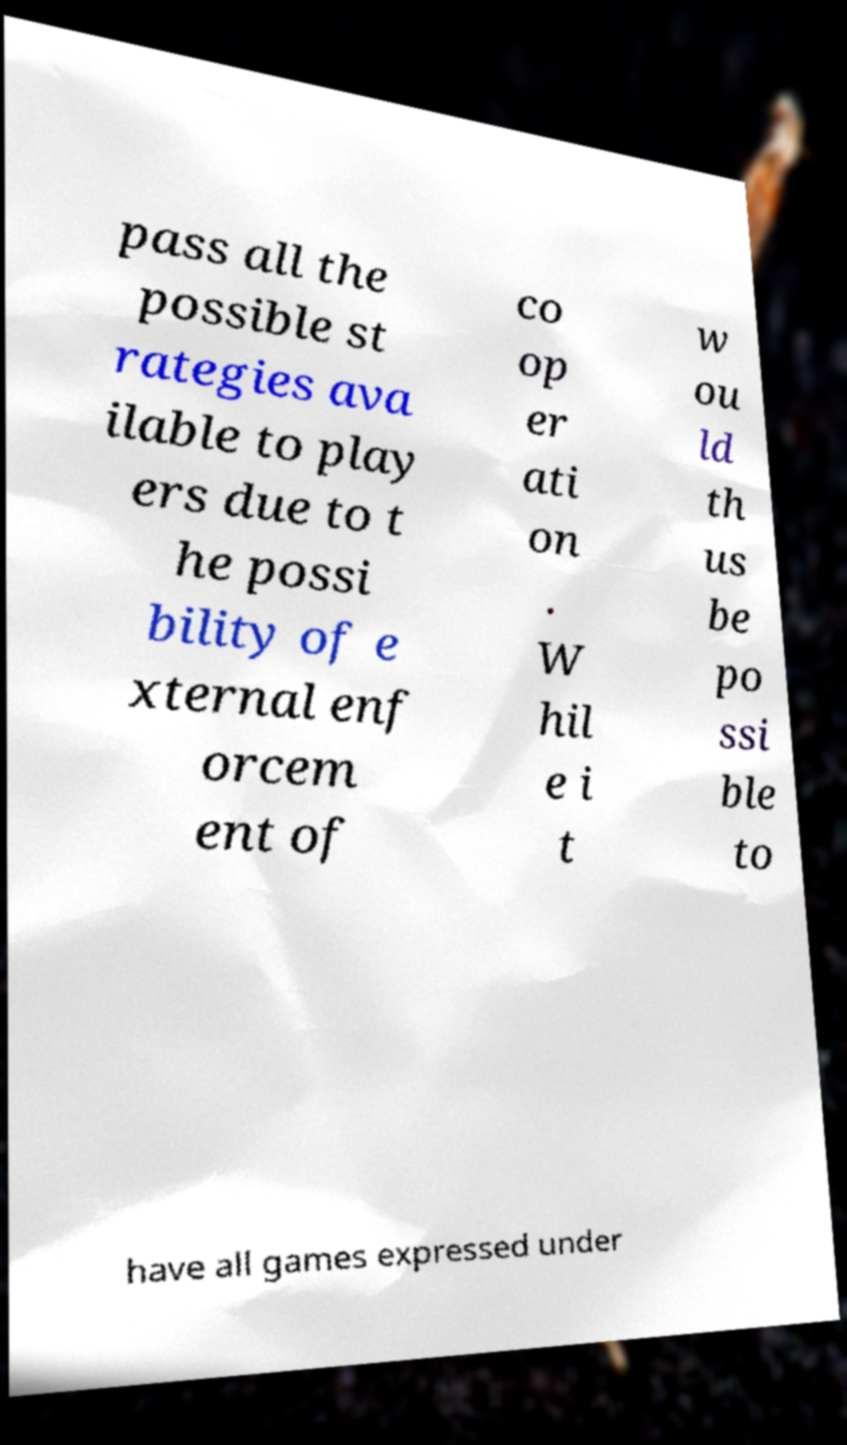Please identify and transcribe the text found in this image. pass all the possible st rategies ava ilable to play ers due to t he possi bility of e xternal enf orcem ent of co op er ati on . W hil e i t w ou ld th us be po ssi ble to have all games expressed under 